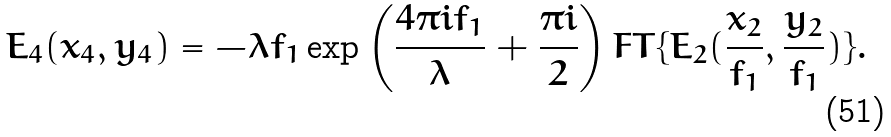Convert formula to latex. <formula><loc_0><loc_0><loc_500><loc_500>E _ { 4 } ( x _ { 4 } , y _ { 4 } ) = - \lambda f _ { 1 } \exp \left ( \frac { 4 \pi i f _ { 1 } } { \lambda } + \frac { \pi i } { 2 } \right ) F T \{ E _ { 2 } ( \frac { x _ { 2 } } { f _ { 1 } } , \frac { y _ { 2 } } { f _ { 1 } } ) \} .</formula> 